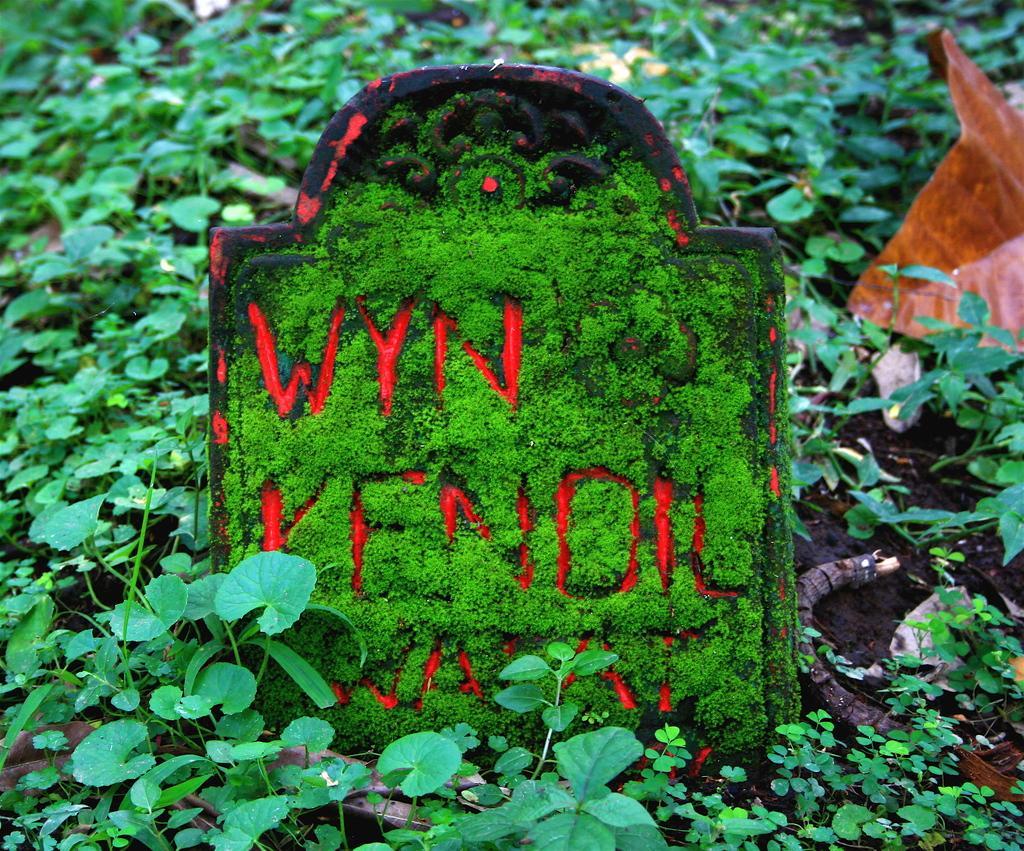Describe this image in one or two sentences. In this picture, we can see the ground with plants, and some objects on the ground, and among them we can see an object with some text. 